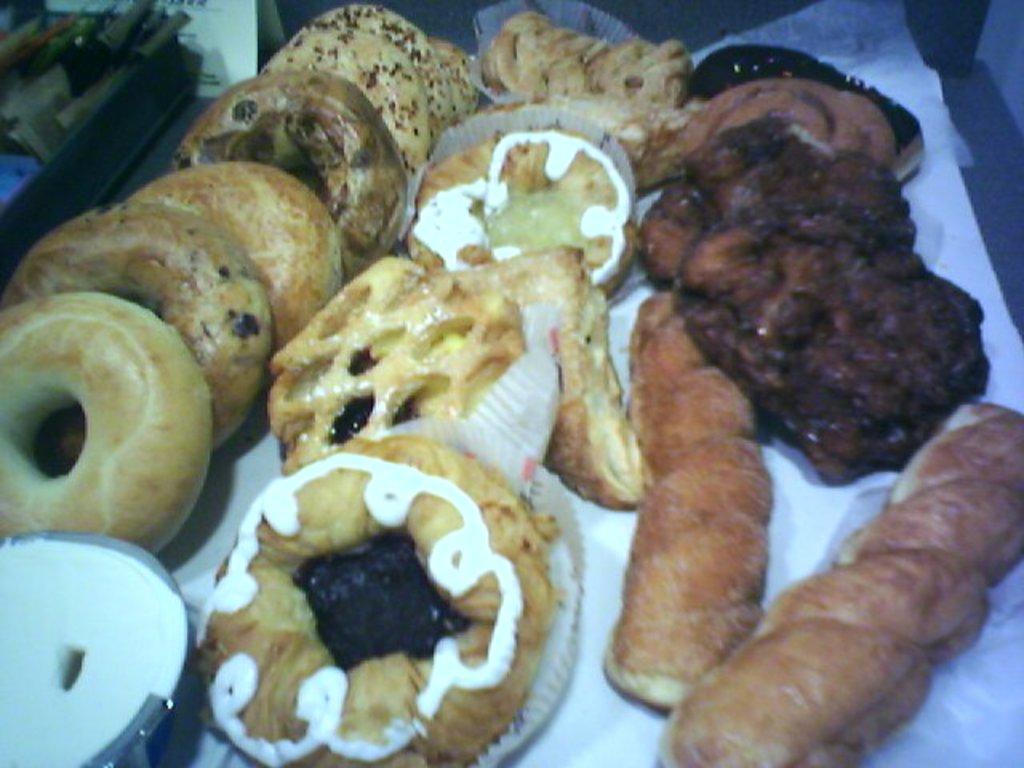Can you describe this image briefly? this picture shows all the food items. here we can see some donuts and puffs and rolls and a white sauce. 